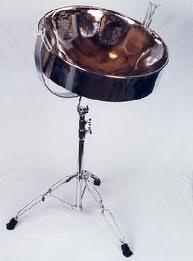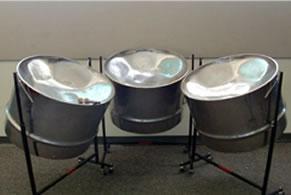The first image is the image on the left, the second image is the image on the right. For the images displayed, is the sentence "There are 7 drums total." factually correct? Answer yes or no. No. The first image is the image on the left, the second image is the image on the right. Given the left and right images, does the statement "Each image features a drum style with a concave top mounted on a pivoting stand, but one image contains one fewer bowl drum than the other image." hold true? Answer yes or no. No. 